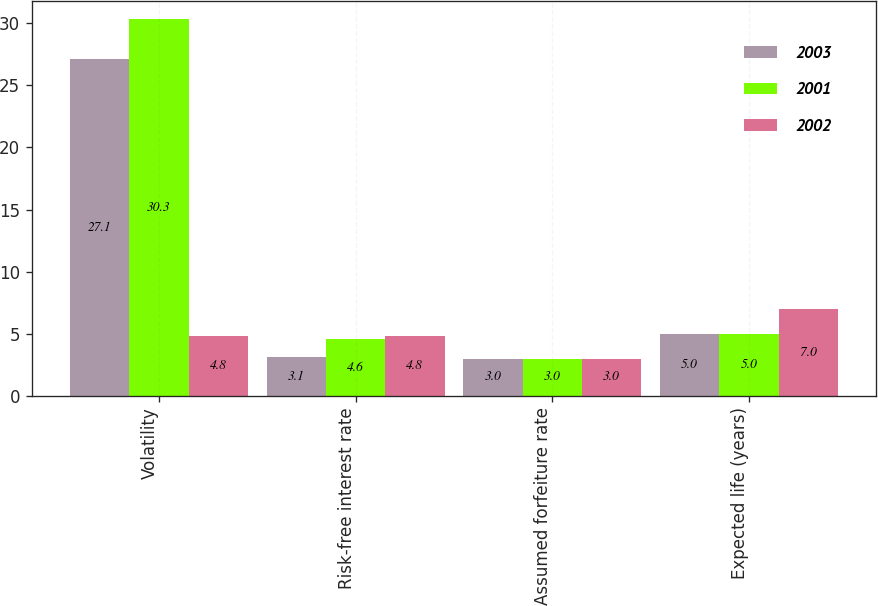<chart> <loc_0><loc_0><loc_500><loc_500><stacked_bar_chart><ecel><fcel>Volatility<fcel>Risk-free interest rate<fcel>Assumed forfeiture rate<fcel>Expected life (years)<nl><fcel>2003<fcel>27.1<fcel>3.1<fcel>3<fcel>5<nl><fcel>2001<fcel>30.3<fcel>4.6<fcel>3<fcel>5<nl><fcel>2002<fcel>4.8<fcel>4.8<fcel>3<fcel>7<nl></chart> 